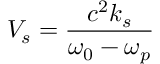<formula> <loc_0><loc_0><loc_500><loc_500>V _ { s } = \frac { c ^ { 2 } k _ { s } } { \omega _ { 0 } - \omega _ { p } }</formula> 